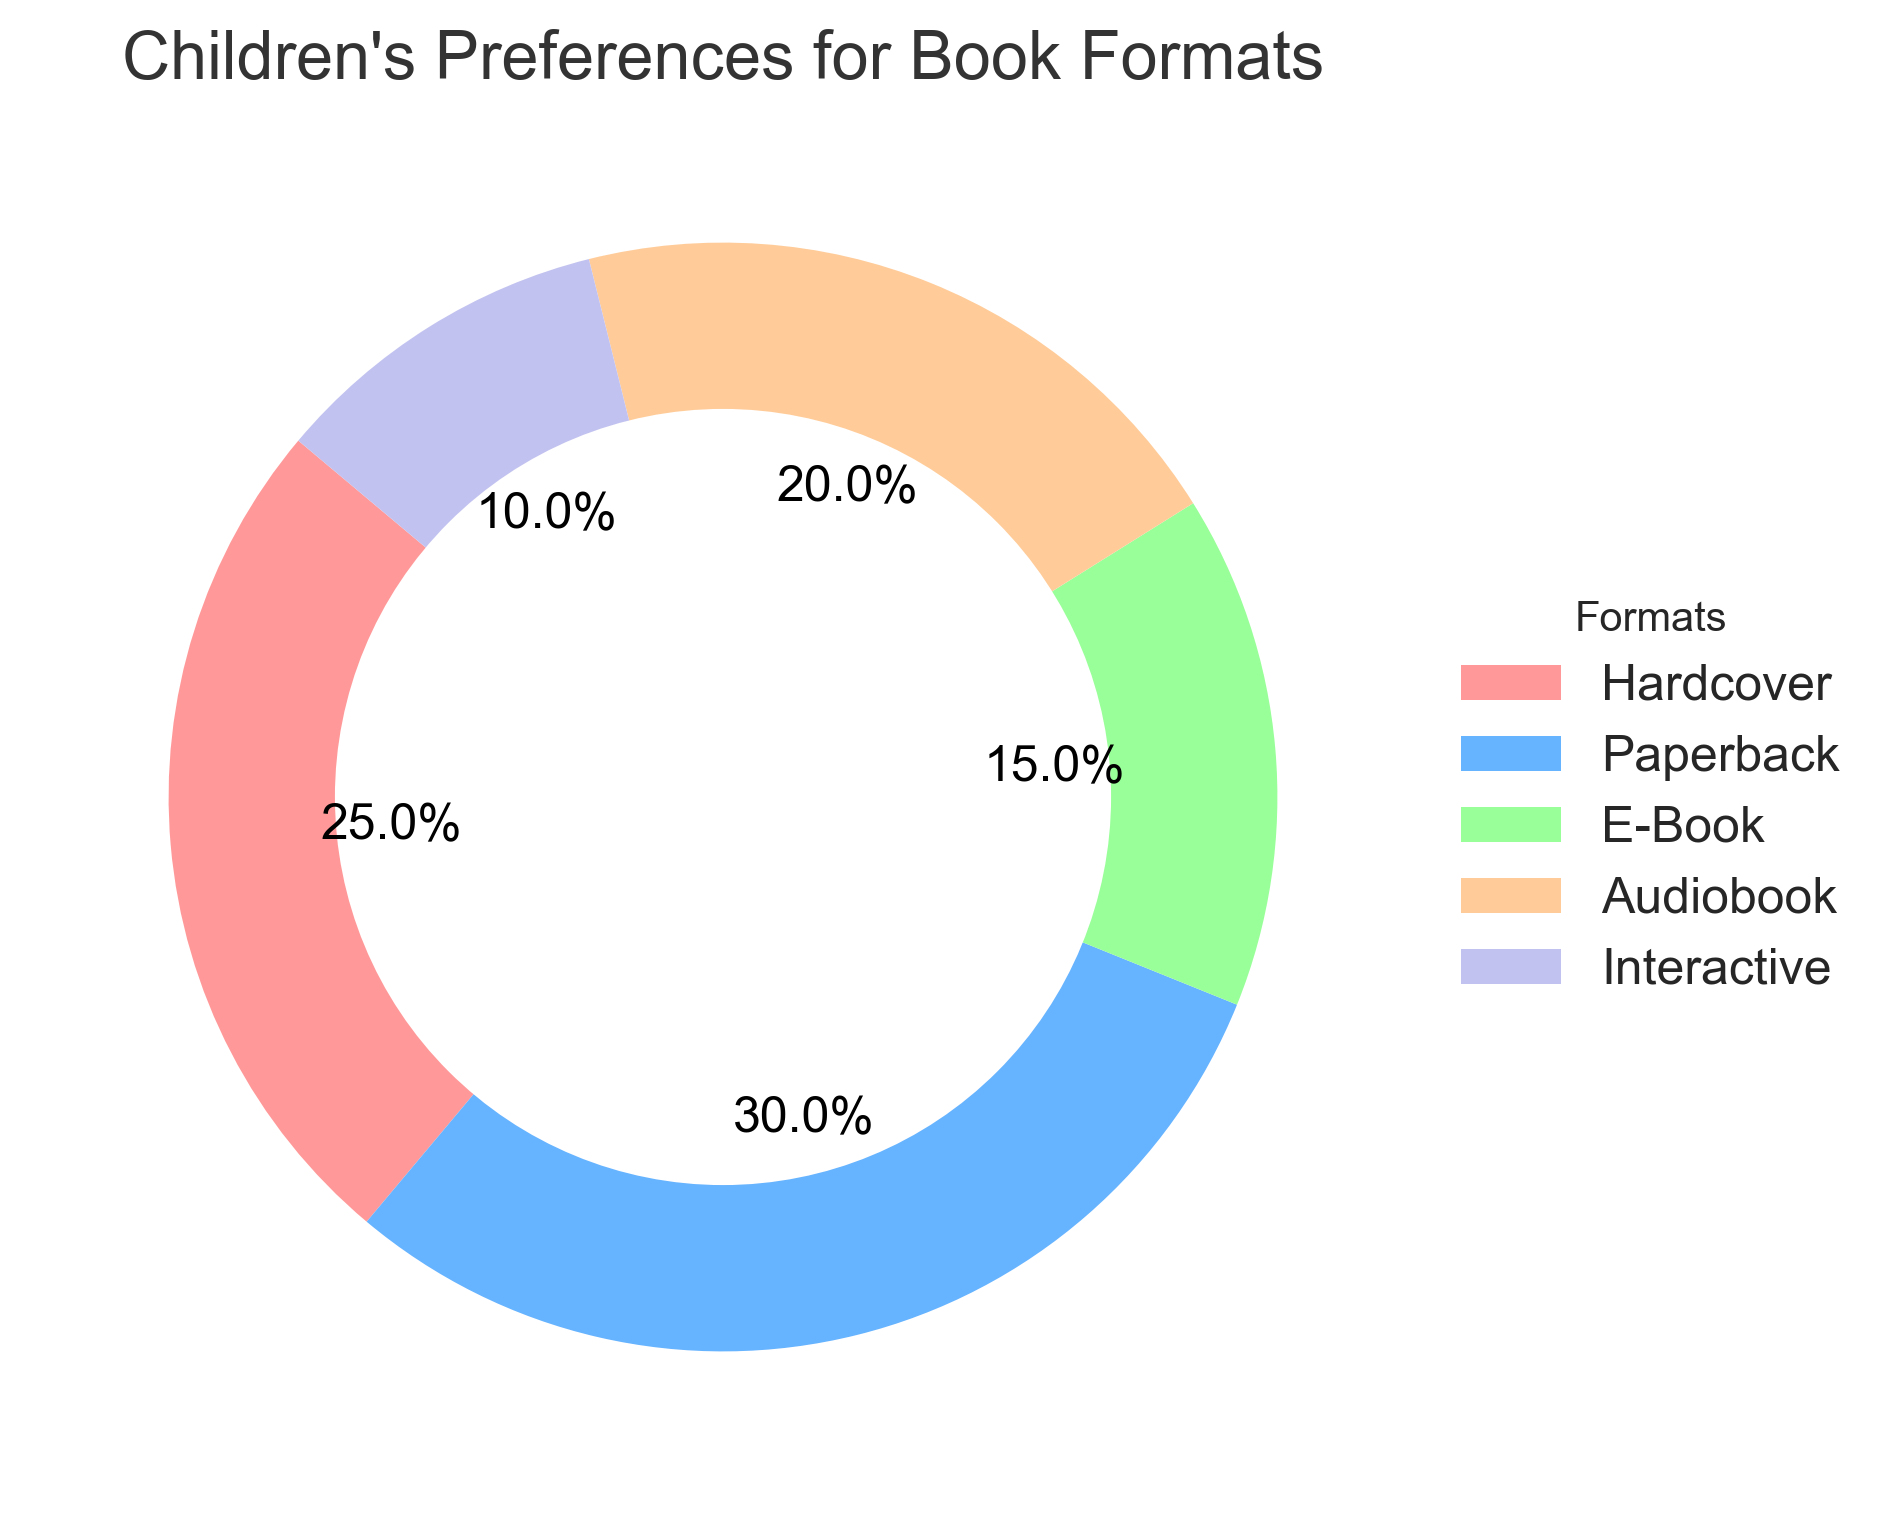Which book format is the most preferred by children? The pie chart shows percentages for each book format. Paperback has the highest percentage at 30%, making it the most preferred format.
Answer: Paperback Which two book formats together make up more than 50% of children's preferences? By adding the percentages, Hardcover (25%) and Paperback (30%) together make up 55%, which is more than 50%.
Answer: Hardcover and Paperback What percentage difference is there between the most and least preferred book formats? The most preferred format is Paperback at 30% and the least preferred is Interactive at 10%. The difference is calculated as 30% - 10% = 20%.
Answer: 20% Which book format is preferred more than Audiobook but less than Paperback? From the pie chart, Hardcover is preferred more than Audiobook (Hardcover 25%, Audiobook 20%) and less than Paperback (Paperback 30%).
Answer: Hardcover How much more popular is the Paperback format compared to the Interactive format? The percentage for Paperback is 30% and for Interactive, it is 10%. The difference is calculated as 30% - 10% = 20%.
Answer: 20% What is the combined preference percentage for digital formats like E-Book and Interactive? Summing the percentages, E-Book has 15% and Interactive has 10%. The combined percentage is 15% + 10% = 25%.
Answer: 25% If 200 children were surveyed, how many preferred Audiobooks? From the pie chart, 20% of children prefer Audiobooks. Multiplying 20% by 200 children gives 200 * 0.20 = 40 children.
Answer: 40 Which format has a percentage that falls between the percentages of Hardcover and E-Book? The pie chart shows that Audiobook at 20% falls between Hardcover (25%) and E-Book (15%).
Answer: Audiobook What is the ratio of children who prefer Paperback to those who prefer Interactive books? The percentage for Paperback is 30%, and for Interactive, it is 10%. The ratio is calculated as 30% / 10% = 3.
Answer: 3:1 If the least popular format doubled in preference percentage, how would that affect its ranking? The least popular format, Interactive, has 10%. If doubled, it would be 20%, equaling Audiobook. Its rank would improve from last to tied for third.
Answer: Tied for third 